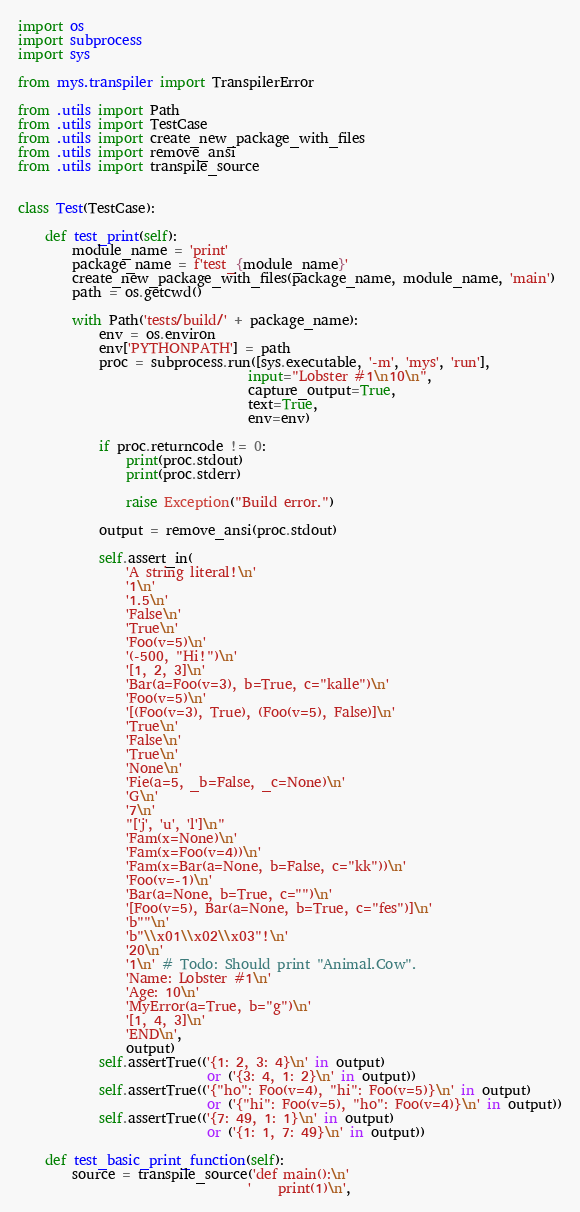<code> <loc_0><loc_0><loc_500><loc_500><_Python_>import os
import subprocess
import sys

from mys.transpiler import TranspilerError

from .utils import Path
from .utils import TestCase
from .utils import create_new_package_with_files
from .utils import remove_ansi
from .utils import transpile_source


class Test(TestCase):

    def test_print(self):
        module_name = 'print'
        package_name = f'test_{module_name}'
        create_new_package_with_files(package_name, module_name, 'main')
        path = os.getcwd()

        with Path('tests/build/' + package_name):
            env = os.environ
            env['PYTHONPATH'] = path
            proc = subprocess.run([sys.executable, '-m', 'mys', 'run'],
                                  input="Lobster #1\n10\n",
                                  capture_output=True,
                                  text=True,
                                  env=env)

            if proc.returncode != 0:
                print(proc.stdout)
                print(proc.stderr)

                raise Exception("Build error.")

            output = remove_ansi(proc.stdout)

            self.assert_in(
                'A string literal!\n'
                '1\n'
                '1.5\n'
                'False\n'
                'True\n'
                'Foo(v=5)\n'
                '(-500, "Hi!")\n'
                '[1, 2, 3]\n'
                'Bar(a=Foo(v=3), b=True, c="kalle")\n'
                'Foo(v=5)\n'
                '[(Foo(v=3), True), (Foo(v=5), False)]\n'
                'True\n'
                'False\n'
                'True\n'
                'None\n'
                'Fie(a=5, _b=False, _c=None)\n'
                'G\n'
                '7\n'
                "['j', 'u', 'l']\n"
                'Fam(x=None)\n'
                'Fam(x=Foo(v=4))\n'
                'Fam(x=Bar(a=None, b=False, c="kk"))\n'
                'Foo(v=-1)\n'
                'Bar(a=None, b=True, c="")\n'
                '[Foo(v=5), Bar(a=None, b=True, c="fes")]\n'
                'b""\n'
                'b"\\x01\\x02\\x03"!\n'
                '20\n'
                '1\n' # Todo: Should print "Animal.Cow".
                'Name: Lobster #1\n'
                'Age: 10\n'
                'MyError(a=True, b="g")\n'
                '[1, 4, 3]\n'
                'END\n',
                output)
            self.assertTrue(('{1: 2, 3: 4}\n' in output)
                            or ('{3: 4, 1: 2}\n' in output))
            self.assertTrue(('{"ho": Foo(v=4), "hi": Foo(v=5)}\n' in output)
                            or ('{"hi": Foo(v=5), "ho": Foo(v=4)}\n' in output))
            self.assertTrue(('{7: 49, 1: 1}\n' in output)
                            or ('{1: 1, 7: 49}\n' in output))

    def test_basic_print_function(self):
        source = transpile_source('def main():\n'
                                  '    print(1)\n',</code> 